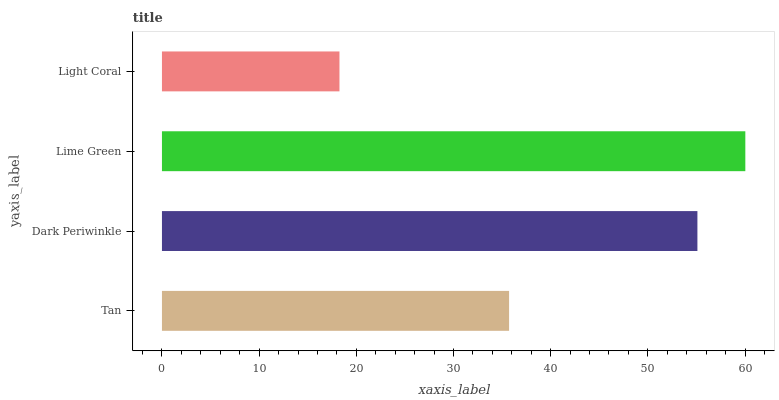Is Light Coral the minimum?
Answer yes or no. Yes. Is Lime Green the maximum?
Answer yes or no. Yes. Is Dark Periwinkle the minimum?
Answer yes or no. No. Is Dark Periwinkle the maximum?
Answer yes or no. No. Is Dark Periwinkle greater than Tan?
Answer yes or no. Yes. Is Tan less than Dark Periwinkle?
Answer yes or no. Yes. Is Tan greater than Dark Periwinkle?
Answer yes or no. No. Is Dark Periwinkle less than Tan?
Answer yes or no. No. Is Dark Periwinkle the high median?
Answer yes or no. Yes. Is Tan the low median?
Answer yes or no. Yes. Is Tan the high median?
Answer yes or no. No. Is Dark Periwinkle the low median?
Answer yes or no. No. 